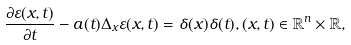<formula> <loc_0><loc_0><loc_500><loc_500>\frac { \partial \varepsilon ( x , t ) } { \partial t } - a ( t ) \Delta _ { x } \varepsilon ( x , t ) = \delta ( x ) \delta ( t ) , ( x , t ) \in \mathbb { R } ^ { n } \times \mathbb { R } ,</formula> 